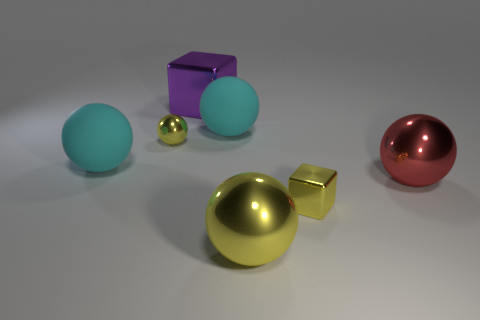Subtract all small yellow metallic spheres. How many spheres are left? 4 Subtract all red spheres. How many spheres are left? 4 Subtract all brown spheres. Subtract all green cubes. How many spheres are left? 5 Add 1 tiny objects. How many objects exist? 8 Subtract all blocks. How many objects are left? 5 Subtract all big purple cylinders. Subtract all matte objects. How many objects are left? 5 Add 3 red things. How many red things are left? 4 Add 3 red metallic balls. How many red metallic balls exist? 4 Subtract 0 green blocks. How many objects are left? 7 